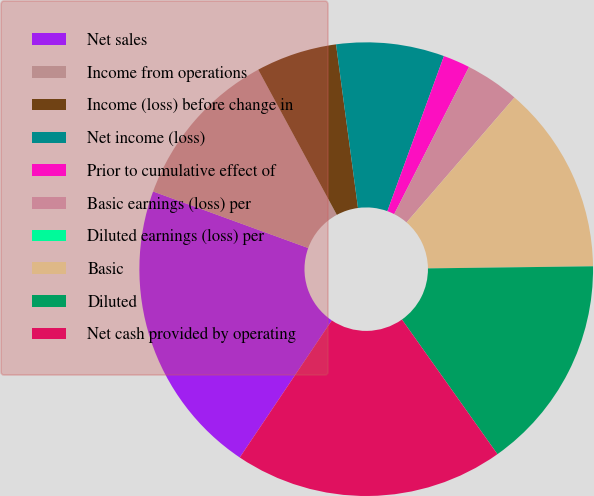Convert chart to OTSL. <chart><loc_0><loc_0><loc_500><loc_500><pie_chart><fcel>Net sales<fcel>Income from operations<fcel>Income (loss) before change in<fcel>Net income (loss)<fcel>Prior to cumulative effect of<fcel>Basic earnings (loss) per<fcel>Diluted earnings (loss) per<fcel>Basic<fcel>Diluted<fcel>Net cash provided by operating<nl><fcel>21.15%<fcel>11.54%<fcel>5.77%<fcel>7.69%<fcel>1.92%<fcel>3.85%<fcel>0.0%<fcel>13.46%<fcel>15.38%<fcel>19.23%<nl></chart> 